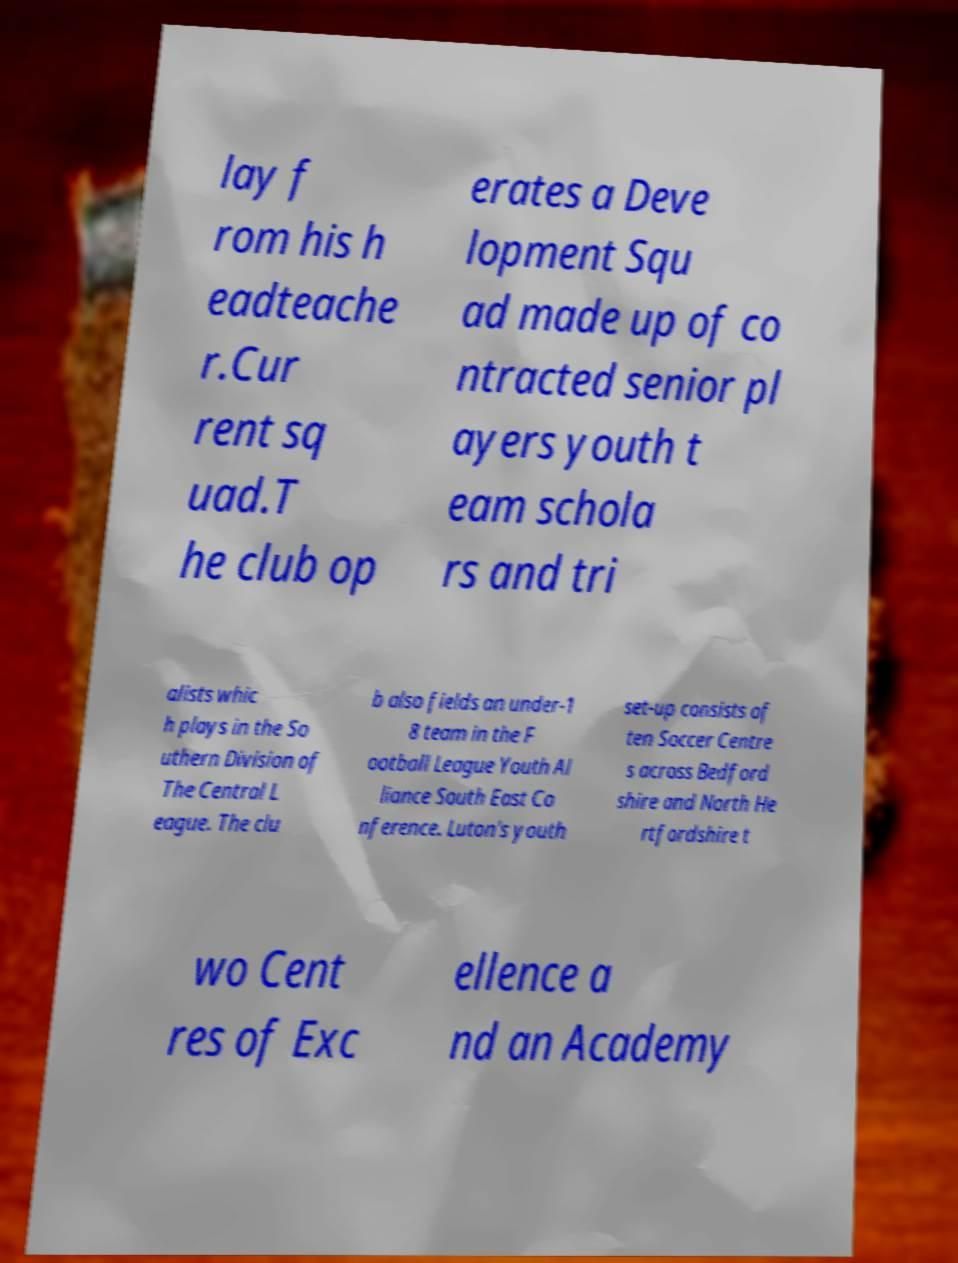Please identify and transcribe the text found in this image. lay f rom his h eadteache r.Cur rent sq uad.T he club op erates a Deve lopment Squ ad made up of co ntracted senior pl ayers youth t eam schola rs and tri alists whic h plays in the So uthern Division of The Central L eague. The clu b also fields an under-1 8 team in the F ootball League Youth Al liance South East Co nference. Luton's youth set-up consists of ten Soccer Centre s across Bedford shire and North He rtfordshire t wo Cent res of Exc ellence a nd an Academy 